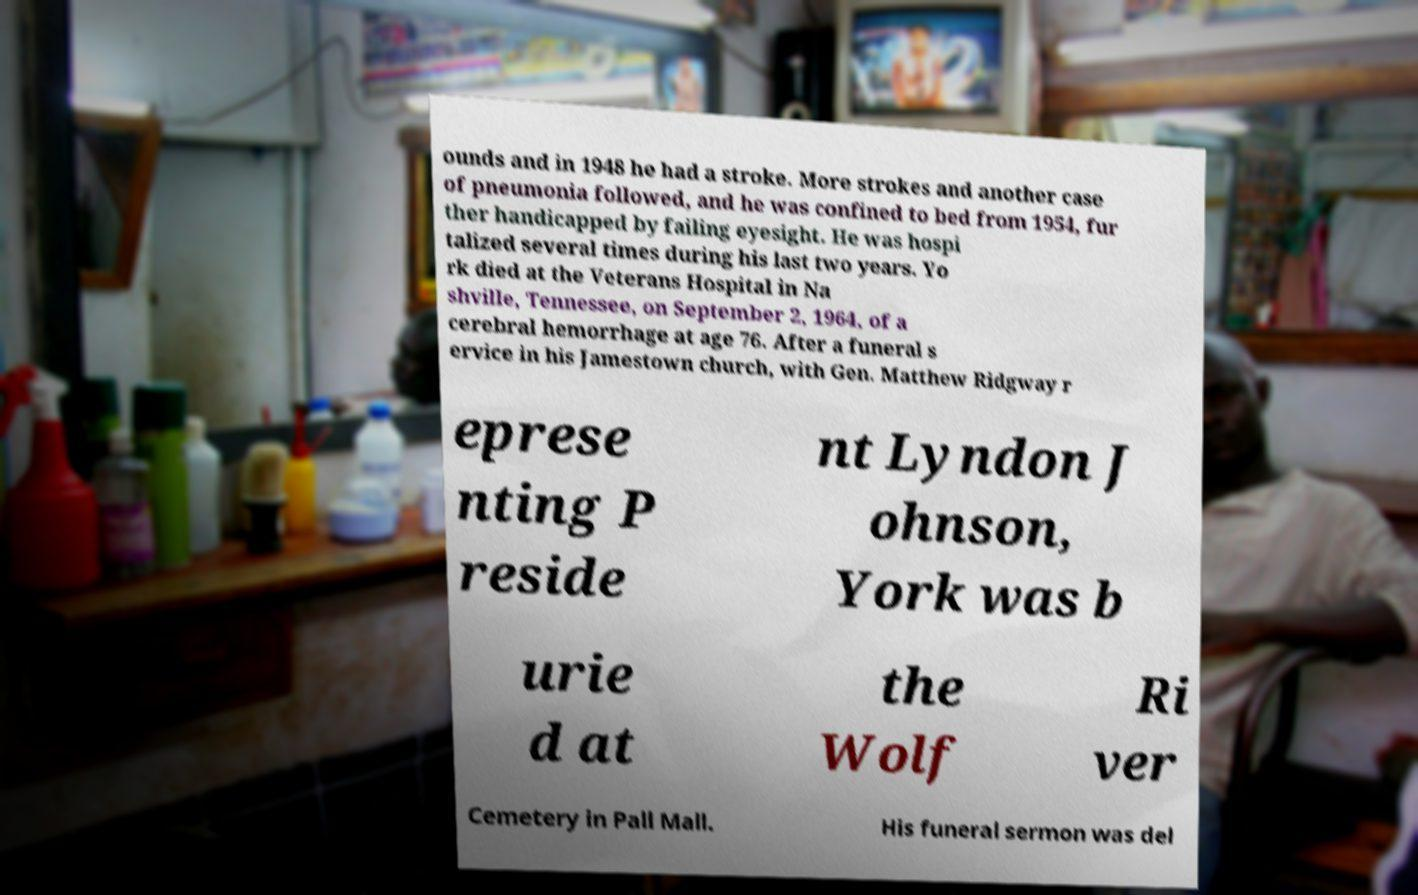Could you assist in decoding the text presented in this image and type it out clearly? ounds and in 1948 he had a stroke. More strokes and another case of pneumonia followed, and he was confined to bed from 1954, fur ther handicapped by failing eyesight. He was hospi talized several times during his last two years. Yo rk died at the Veterans Hospital in Na shville, Tennessee, on September 2, 1964, of a cerebral hemorrhage at age 76. After a funeral s ervice in his Jamestown church, with Gen. Matthew Ridgway r eprese nting P reside nt Lyndon J ohnson, York was b urie d at the Wolf Ri ver Cemetery in Pall Mall. His funeral sermon was del 